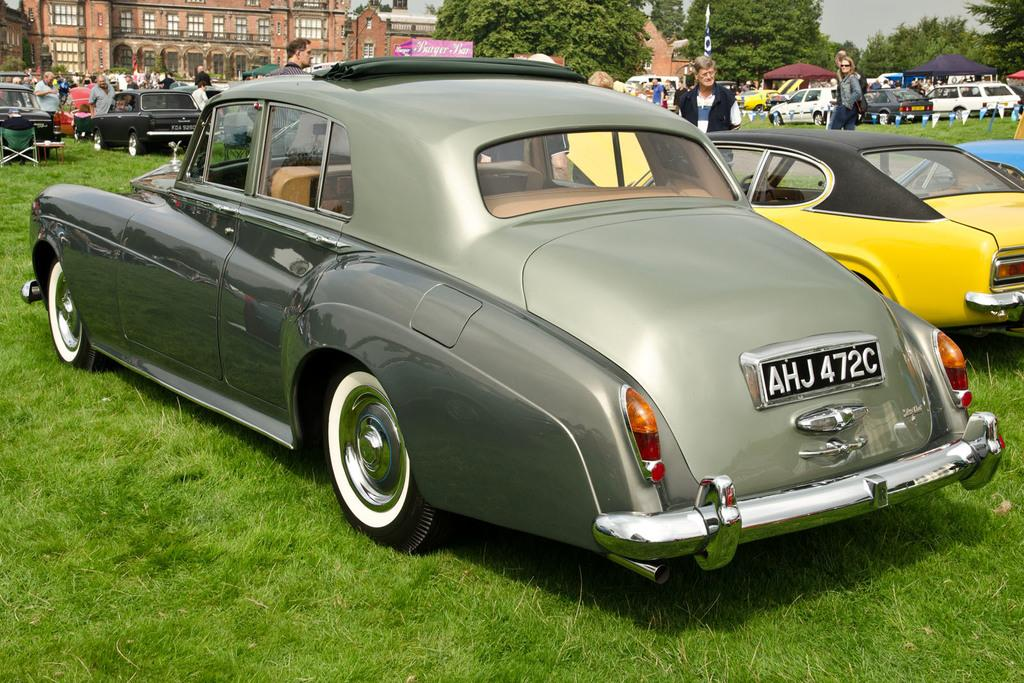What is the main subject of the image? The main subject of the image is many cars on the grassland. What else can be seen in the background of the image? There are people standing all over the place and a building in the background. Are there any trees visible in the image? Yes, trees are beside the building in the image. What type of appliance can be seen in the image? There is no appliance present in the image. What wish is being granted in the image? There is no wish being granted in the image. 